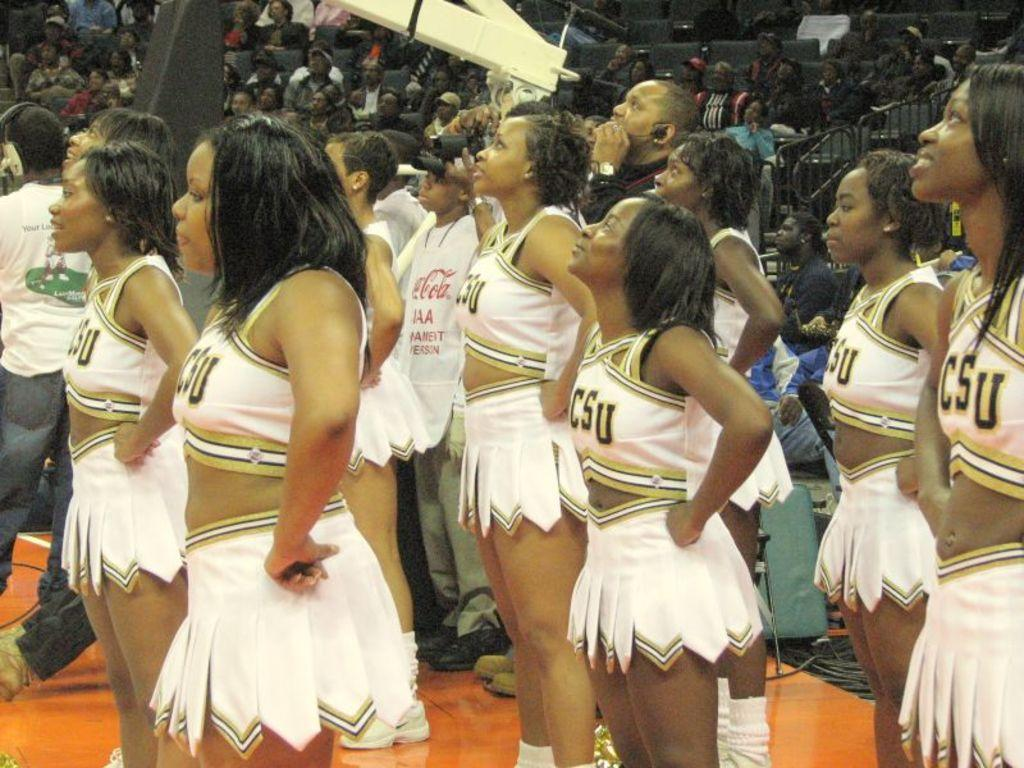<image>
Give a short and clear explanation of the subsequent image. CSU cheerleaders wearing white outfits stand with their hands on their hips looking up. 